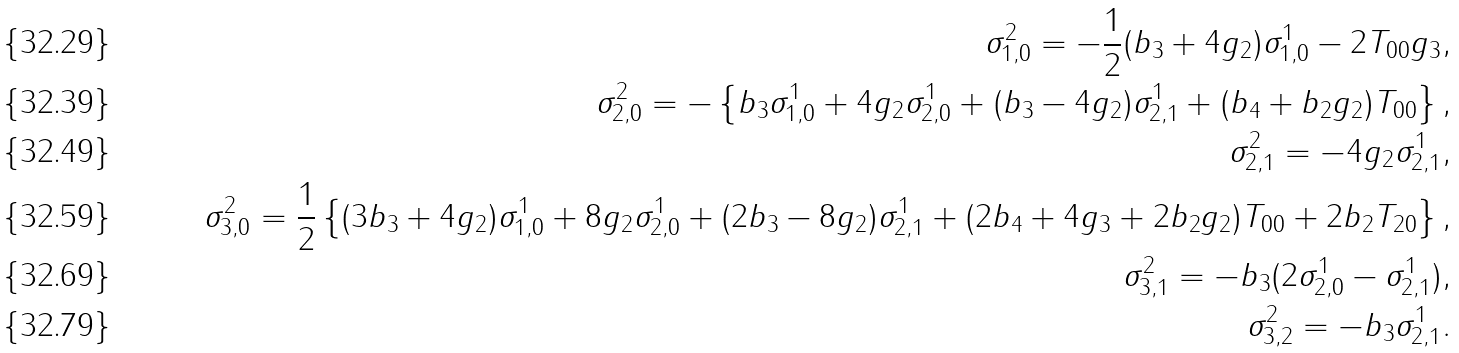Convert formula to latex. <formula><loc_0><loc_0><loc_500><loc_500>\sigma _ { 1 , 0 } ^ { 2 } = - \frac { 1 } { 2 } ( b _ { 3 } + 4 g _ { 2 } ) \sigma _ { 1 , 0 } ^ { 1 } - 2 T _ { 0 0 } g _ { 3 } , \\ \sigma _ { 2 , 0 } ^ { 2 } = - \left \{ b _ { 3 } \sigma _ { 1 , 0 } ^ { 1 } + 4 g _ { 2 } \sigma _ { 2 , 0 } ^ { 1 } + ( b _ { 3 } - 4 g _ { 2 } ) \sigma _ { 2 , 1 } ^ { 1 } + ( b _ { 4 } + b _ { 2 } g _ { 2 } ) T _ { 0 0 } \right \} , \\ \sigma _ { 2 , 1 } ^ { 2 } = - 4 g _ { 2 } \sigma _ { 2 , 1 } ^ { 1 } , \\ \sigma _ { 3 , 0 } ^ { 2 } = \frac { 1 } { 2 } \left \{ ( 3 b _ { 3 } + 4 g _ { 2 } ) \sigma _ { 1 , 0 } ^ { 1 } + 8 g _ { 2 } \sigma _ { 2 , 0 } ^ { 1 } + ( 2 b _ { 3 } - 8 g _ { 2 } ) \sigma _ { 2 , 1 } ^ { 1 } + ( 2 b _ { 4 } + 4 g _ { 3 } + 2 b _ { 2 } g _ { 2 } ) T _ { 0 0 } + 2 b _ { 2 } T _ { 2 0 } \right \} , \\ \sigma _ { 3 , 1 } ^ { 2 } = - b _ { 3 } ( 2 \sigma _ { 2 , 0 } ^ { 1 } - \sigma _ { 2 , 1 } ^ { 1 } ) , \\ \sigma _ { 3 , 2 } ^ { 2 } = - b _ { 3 } \sigma _ { 2 , 1 } ^ { 1 } .</formula> 